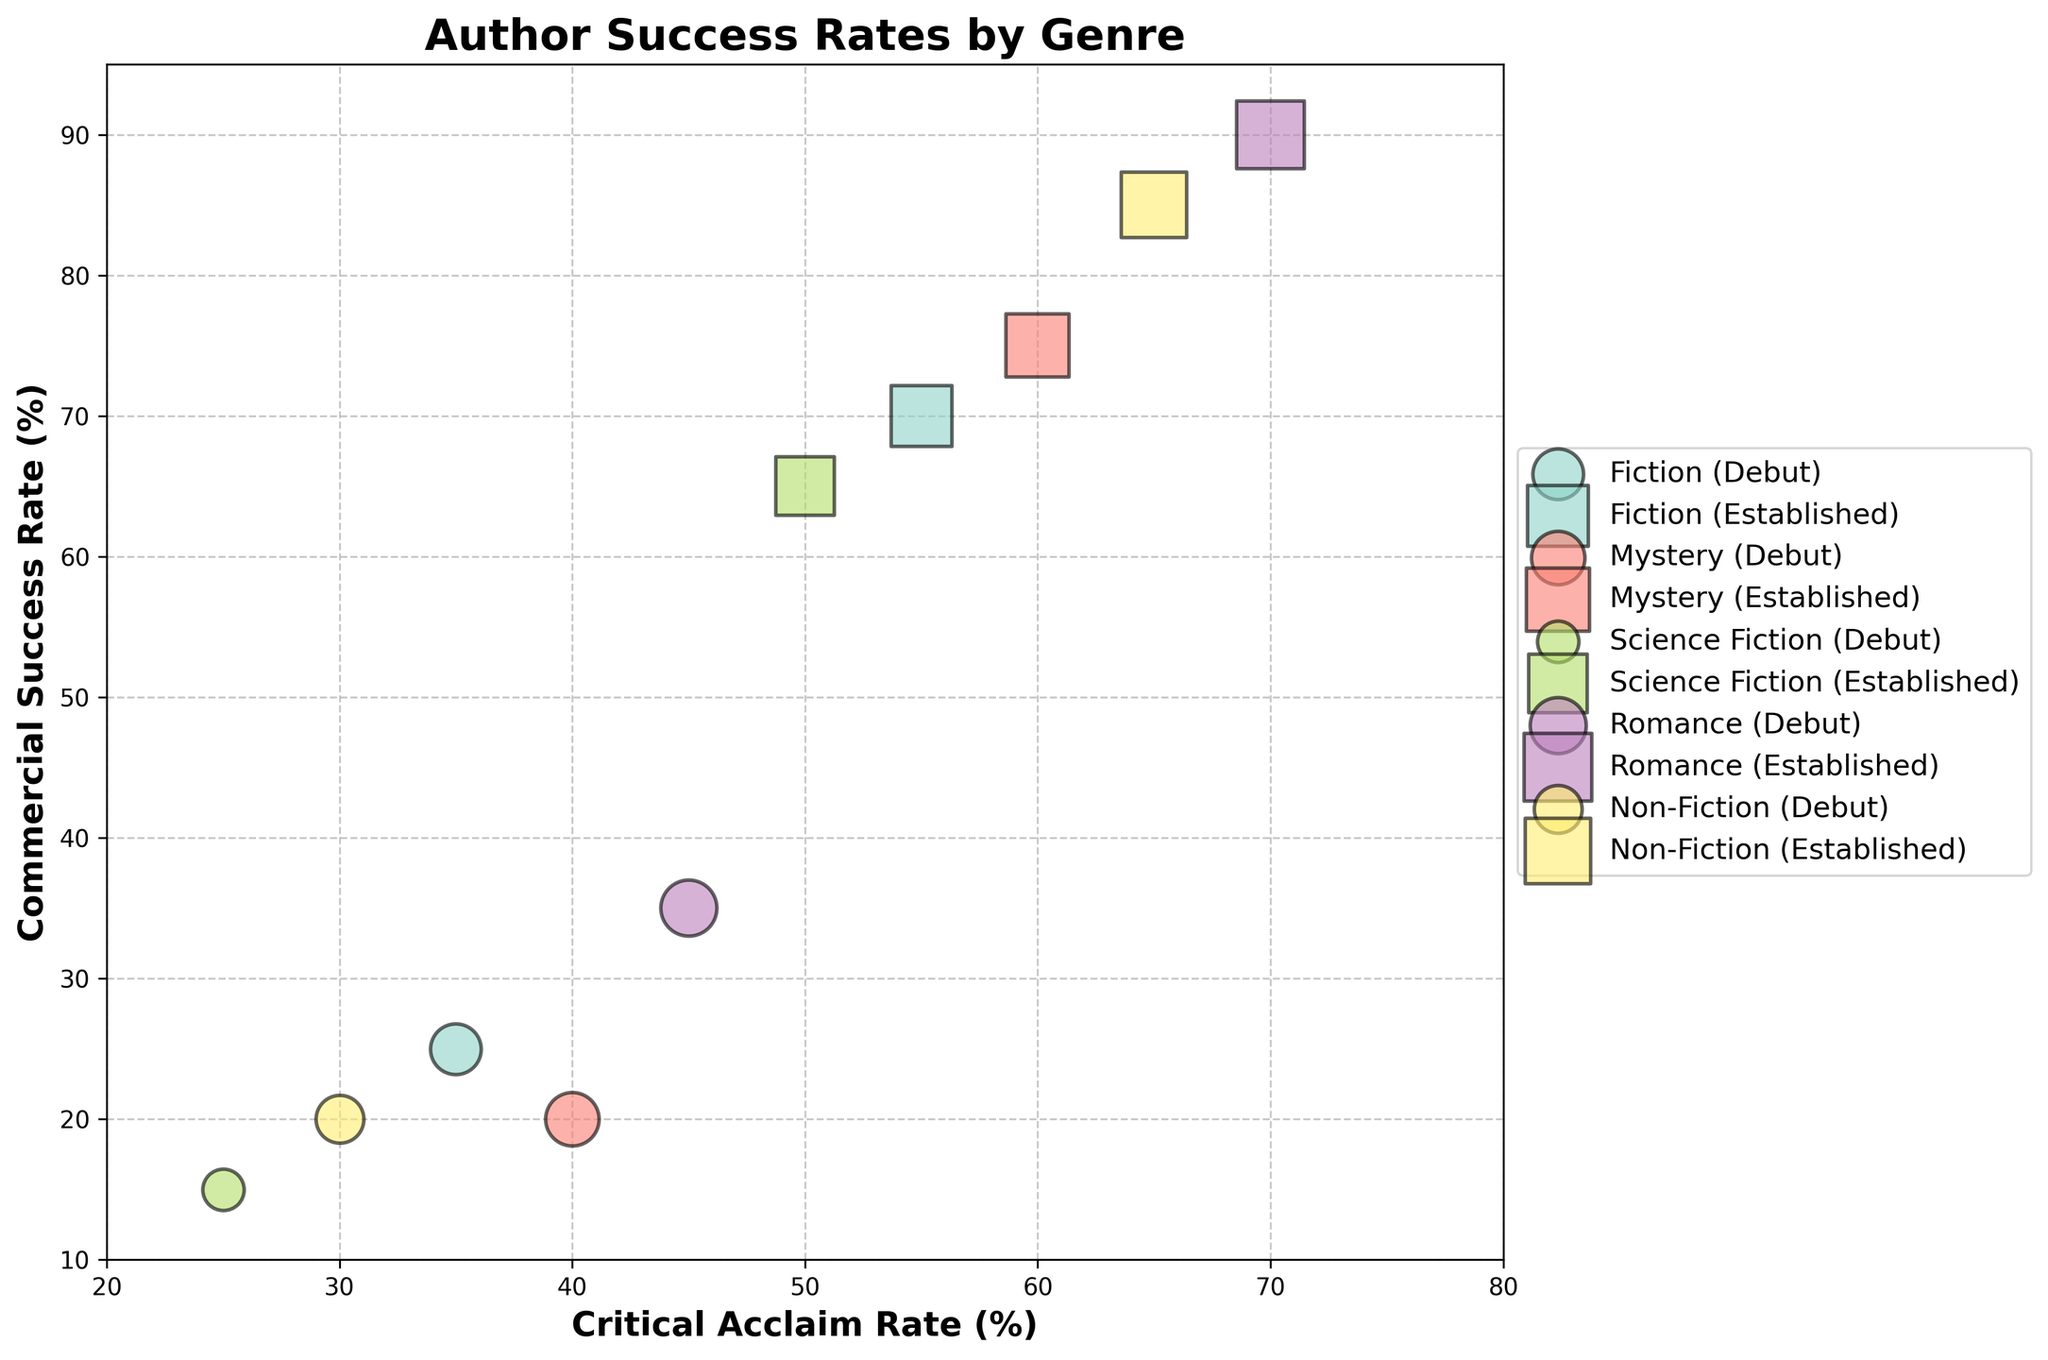Which genre has the highest commercial success rate for established authors? Look for the genre with the largest bubbles on the y-axis for established authors. Romance has the highest y-value around 90%.
Answer: Romance What is the critical acclaim rate for debut authors in Science Fiction? Find the x-axis value for the debut bubble in Science Fiction. The debut bubble for Science Fiction on the x-axis is 25%.
Answer: 25% How does the success rate of debut authors in Fiction compare to the commercial success rate of established authors in the same genre? Find the success rates for Fiction. Debut success rate is on the x-axis at 25%, while the established commercial success rate is on the y-axis at 70%.
Answer: Debut success rate is lower What is the difference in critical acclaim rates between debut and established authors in Mystery? Subtract the critical acclaim rate for debut authors from established authors in Mystery. The difference between 60% (established) - 40% (debut) is 20%.
Answer: 20% Which genre has the equal success rate for both debut and established authors? Look for genres where the debut and established bubbles overlap. Both Fiction and Mystery have equal success rates.
Answer: Fiction, Mystery What are the axes labels in the plot? The axes labels are found on the perimeter of the plot. The x-axis is labeled "Critical Acclaim Rate (%)" and the y-axis is labeled "Commercial Success Rate (%)".
Answer: Critical Acclaim Rate (%) and Commercial Success Rate (%) Which genre shows the largest difference in commercial success between debut and established authors? Compare the bubbles on the y-axis for each genre, looking for the largest vertical distance. Non-Fiction shows a large difference: (85% - 20%) = 65%.
Answer: Non-Fiction In terms of established authors, which genre has the lowest critical acclaim rate? Look at the x-values for the established author squares, and find the lowest. Science Fiction has the lowest critical acclaim rate at 50%.
Answer: Science Fiction 